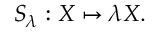Convert formula to latex. <formula><loc_0><loc_0><loc_500><loc_500>S _ { \lambda } \colon X \mapsto \lambda X .</formula> 